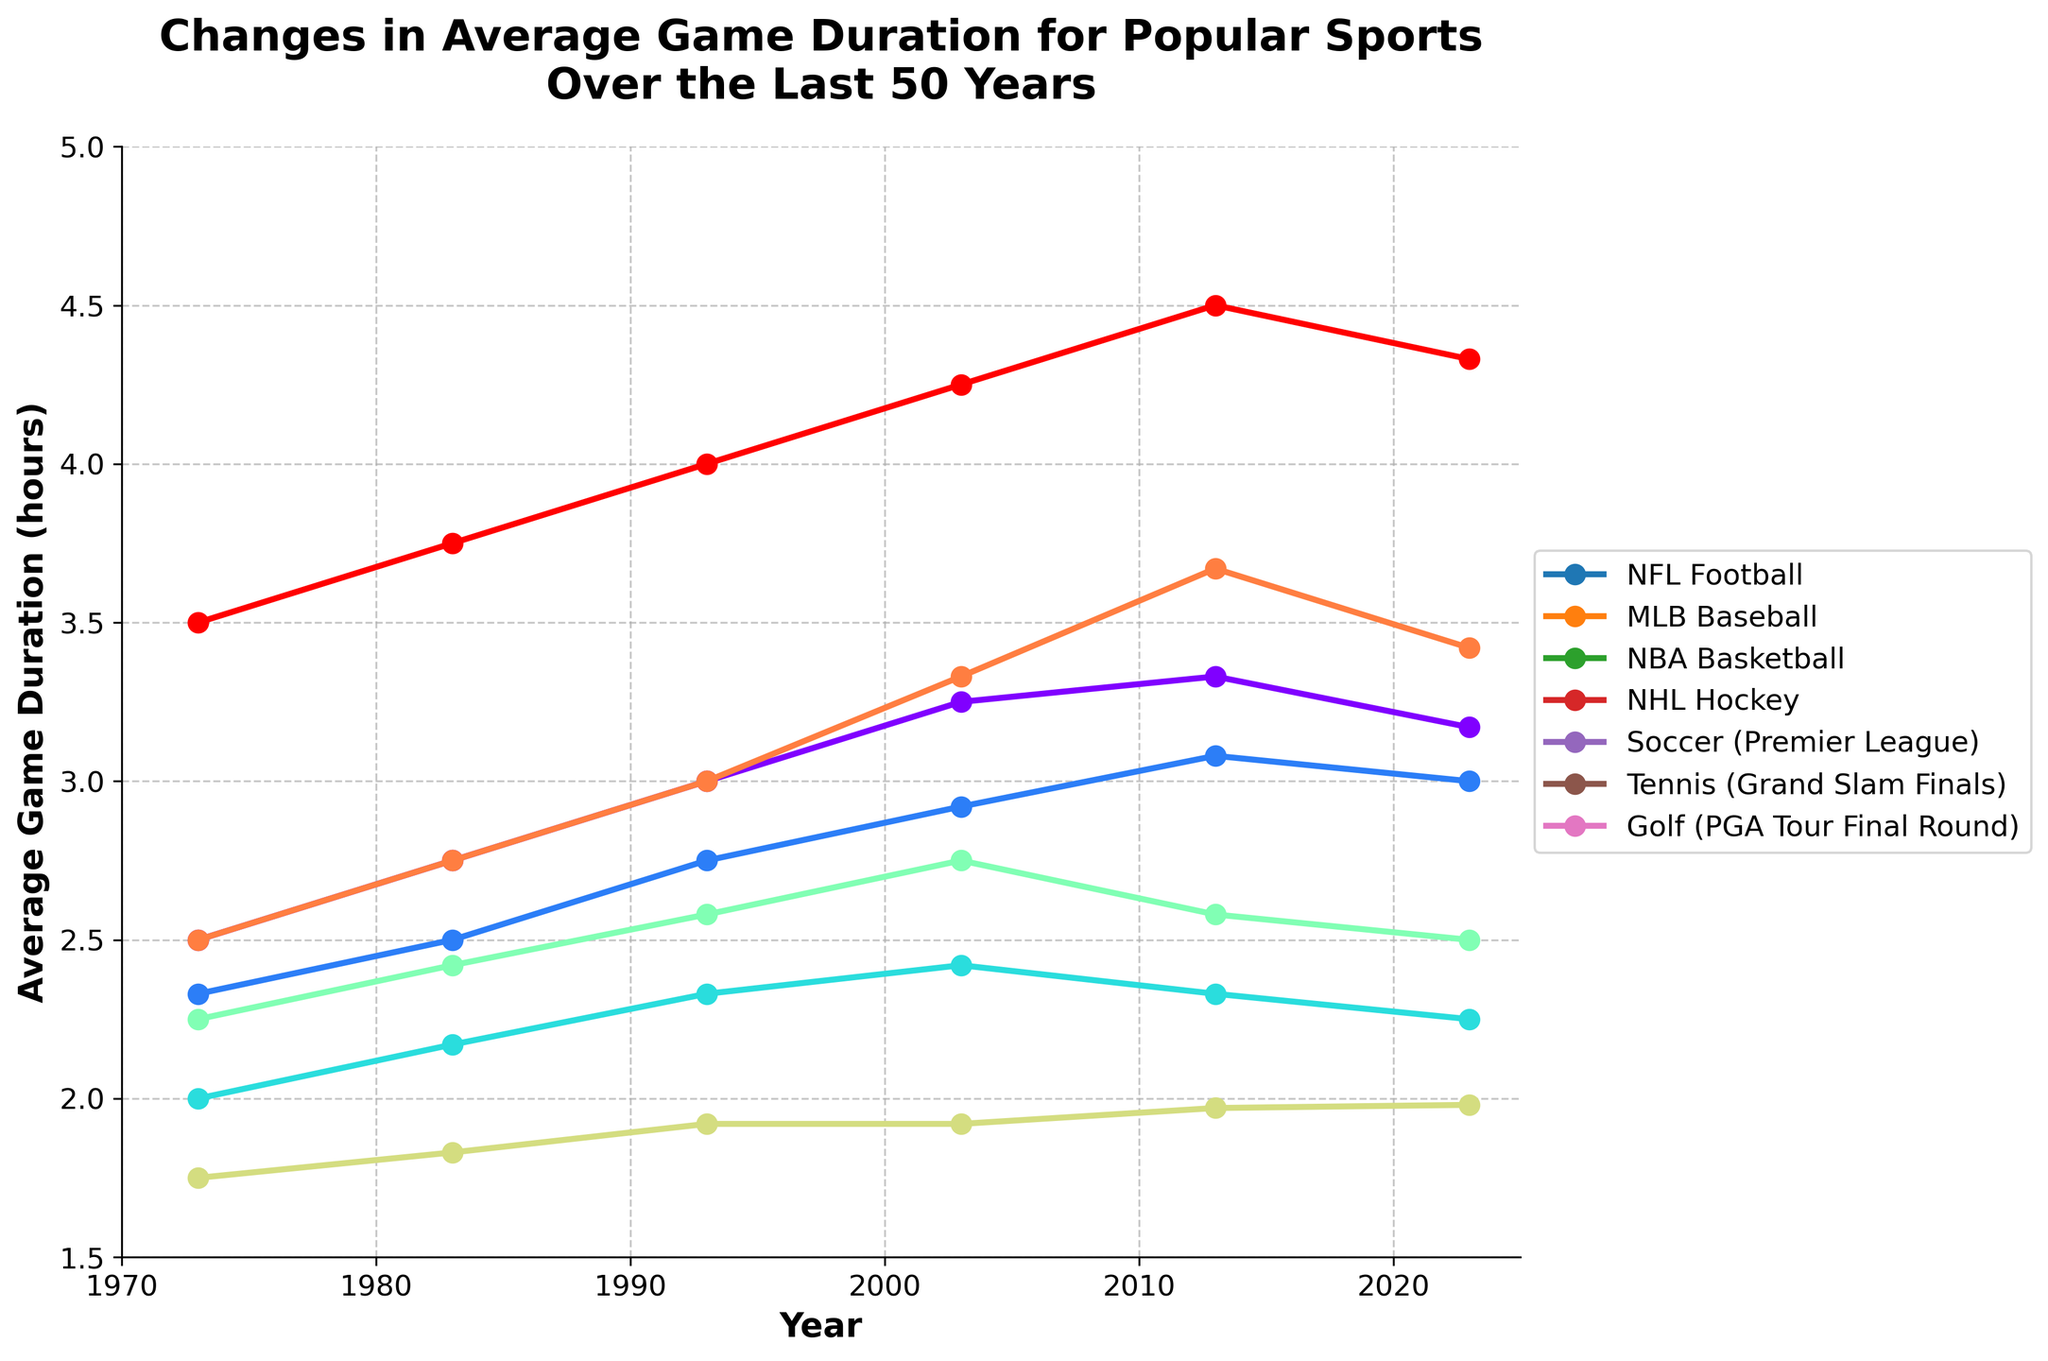Which sport had the longest average game duration in 2023? By looking at the endpoint of the lines on the plot corresponding to 2023, you can see that Golf (PGA Tour Final Round) has the longest average game duration. The line for Golf reaches the highest point in the plot for the year 2023.
Answer: Golf (PGA Tour Final Round) Which sport had the smallest change in average game duration from 1973 to 2023? Compare the differences between the endpoints (2023) and the starting points (1973) of the lines for each sport. Soccer (Premier League) had a change from 1.75 to 1.98 hours, which is the smallest change compared to other sports.
Answer: Soccer (Premier League) How did the average game duration for NFL Football change between 1993 and 2023? Look at the line for NFL Football and note the values for the years 1993 and 2023. In 1993, the duration was 3.0 hours, and in 2023, it was 3.17 hours. Calculate the difference: 3.17 - 3.0 = 0.17 hours.
Answer: Increased by 0.17 hours Which sport experienced the greatest increase in average game duration between 2003 and 2013? Examine all the lines and compare the values for 2003 and 2013. Tennis (Grand Slam Finals) had an increase from 3.33 hours to 3.67 hours, the greatest change among the sports listed.
Answer: Tennis (Grand Slam Finals) What trend can a humorist observer comment on regarding the game duration of NBA Basketball over the years? Looking at the plot line for NBA Basketball, you will see an increase from 1973 to 2003 (from 2.0 to 2.42 hours) and slight declines afterward to 2.25 hours in 2023. Humorously, one might say, "Seems like even the game duration is trying to compete with the 3-point shooting trends – going up fast then slightly coming down!"
Answer: Increase followed by a slight decrease Which sport did not have a continuous increase in average duration over the years? By examining the lines, you'll see the NHL Hockey and NBA Basketball lines show increases to a certain point and then small decreases after that point (NHL decreases from 2.75 hours in 2003 to 2.5 in 2023, NBA from 2.42 in 2003 to 2.25 in 2023).
Answer: NHL Hockey and NBA Basketball On average, how much did the duration of games increase across all sports from 1973 to 2023? Calculate the individual increases for each sport and then find the average. Increases: NFL (0.67), MLB (0.67), NBA (0.25), NHL (0.25), Soccer (0.23), Tennis (0.92), Golf (0.83). The sum is 3.82; divide by 7 sports, resulting in approximately 0.546 hours.
Answer: Approximately 0.55 hours Which sports saw a decrease in average game duration from 2013 to 2023? Compare the values for 2013 and 2023 for each sport. NFL Football decreased from 3.33 to 3.17 hours, MLB Baseball from 3.08 to 3.0 hours, and Tennis from 3.67 to 3.42 hours.
Answer: NFL Football, MLB Baseball, Tennis 